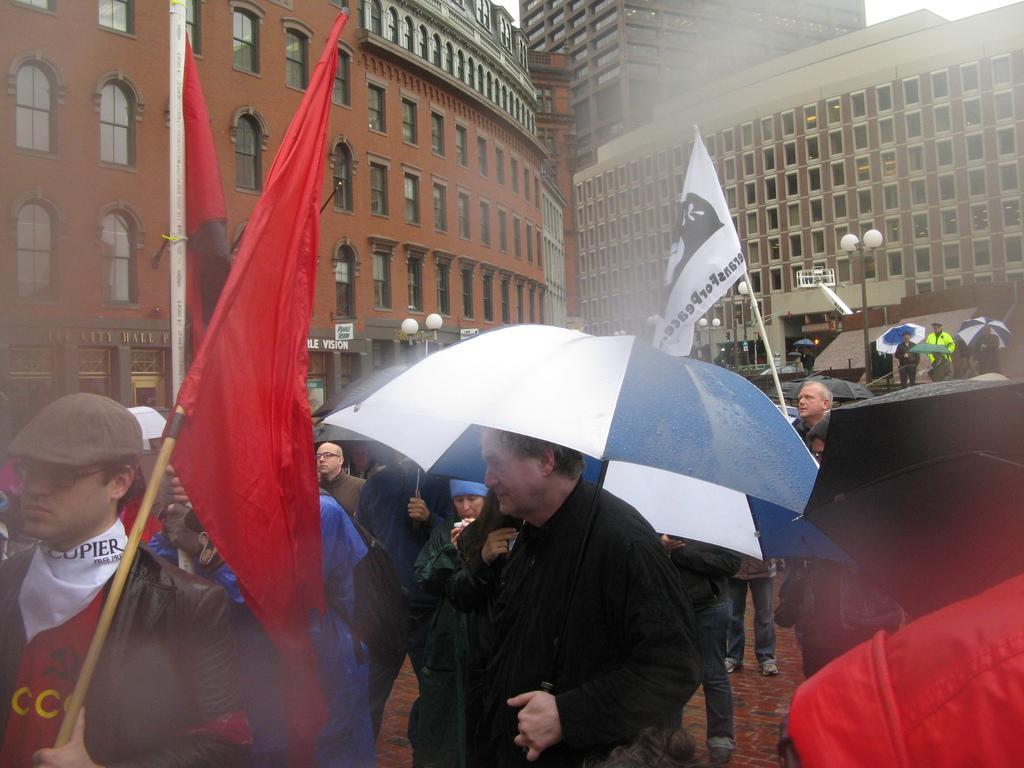Can you describe this image briefly? This image is taken outdoors. In the background there are a few buildings with walls, windows, doors and roofs. There are a few street lights. There is a board with a text on it. In the middle of the image many people are standing on the floor and umbrellas in their hands and a few are holding flags in their hands. 